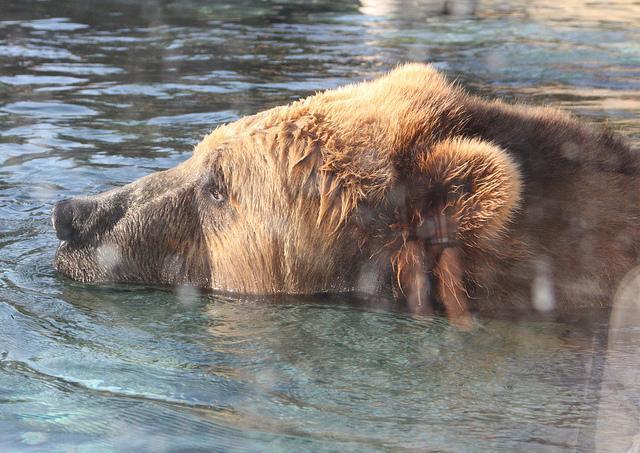How many yellow car in the road?
Give a very brief answer. 0. 